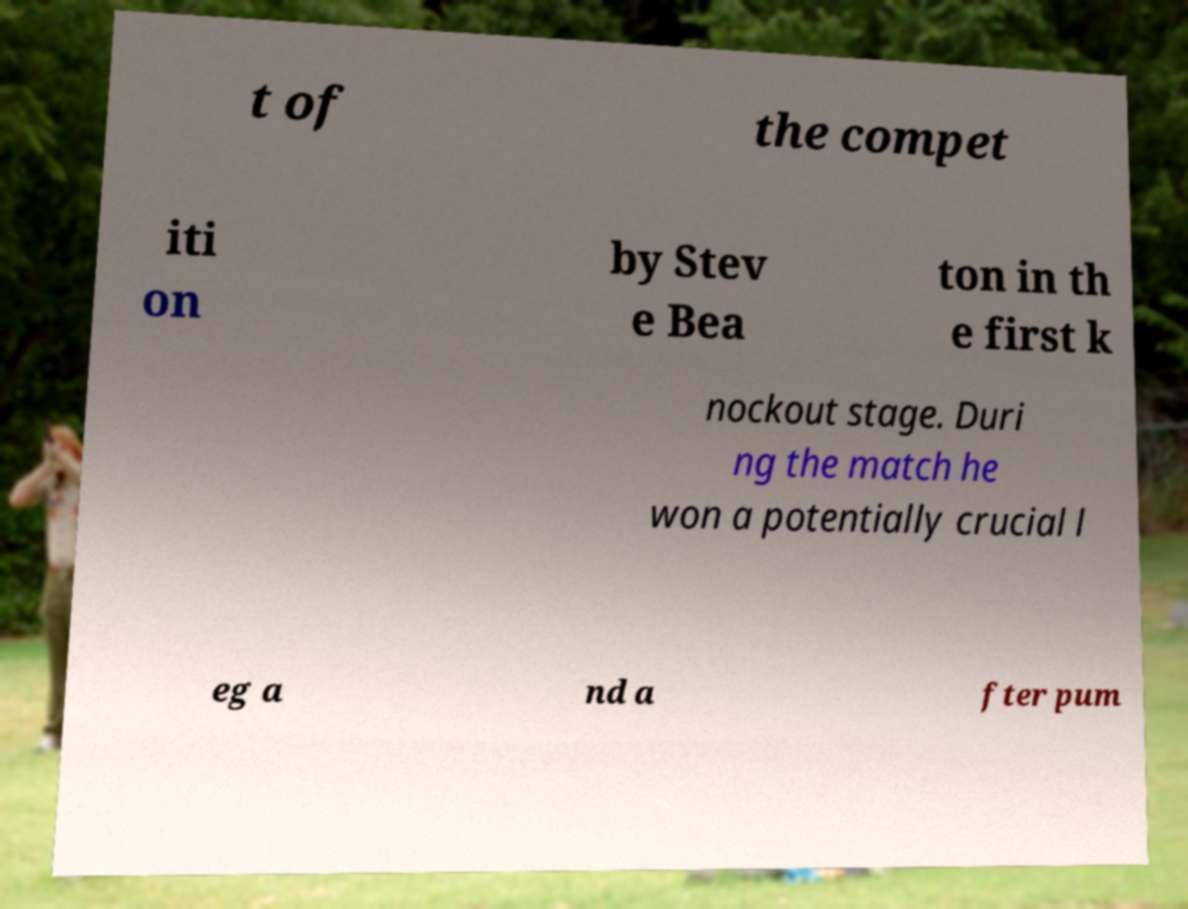Please read and relay the text visible in this image. What does it say? t of the compet iti on by Stev e Bea ton in th e first k nockout stage. Duri ng the match he won a potentially crucial l eg a nd a fter pum 